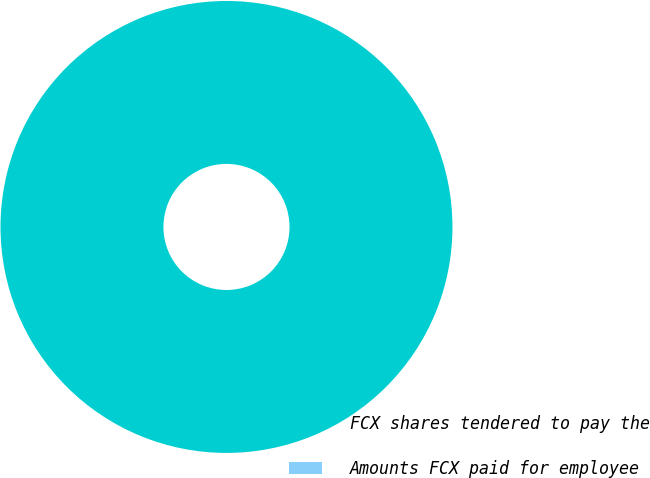Convert chart. <chart><loc_0><loc_0><loc_500><loc_500><pie_chart><fcel>FCX shares tendered to pay the<fcel>Amounts FCX paid for employee<nl><fcel>100.0%<fcel>0.0%<nl></chart> 